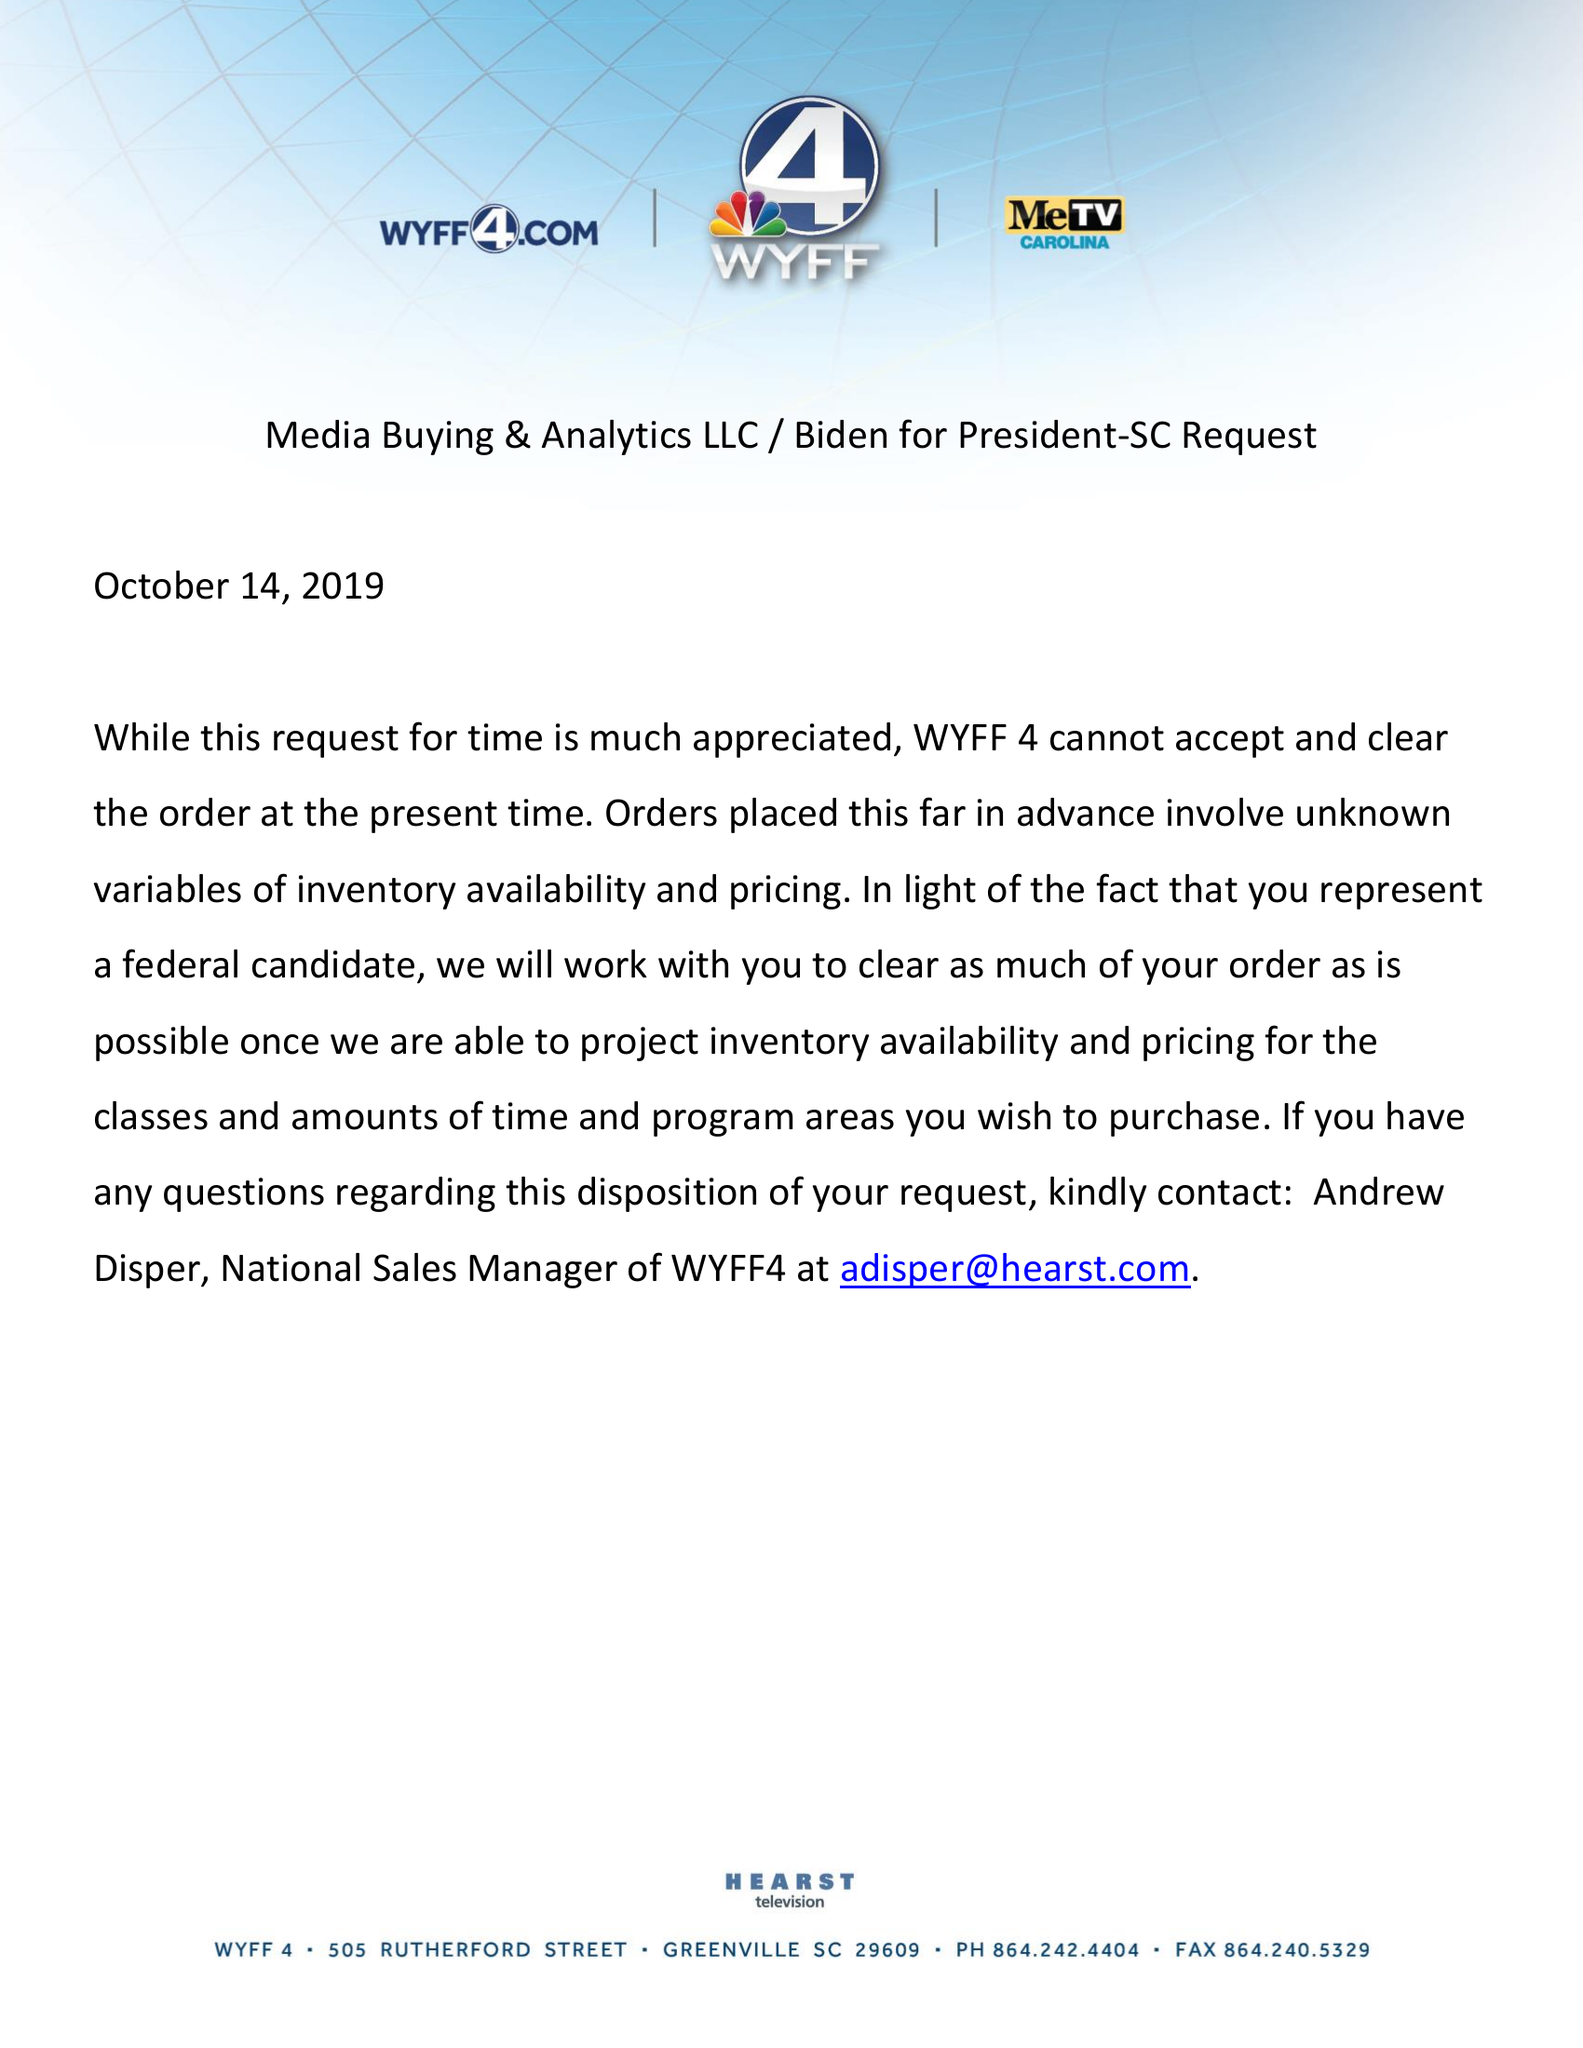What is the value for the advertiser?
Answer the question using a single word or phrase. BIDEN FOR PRESIDENT-SC 